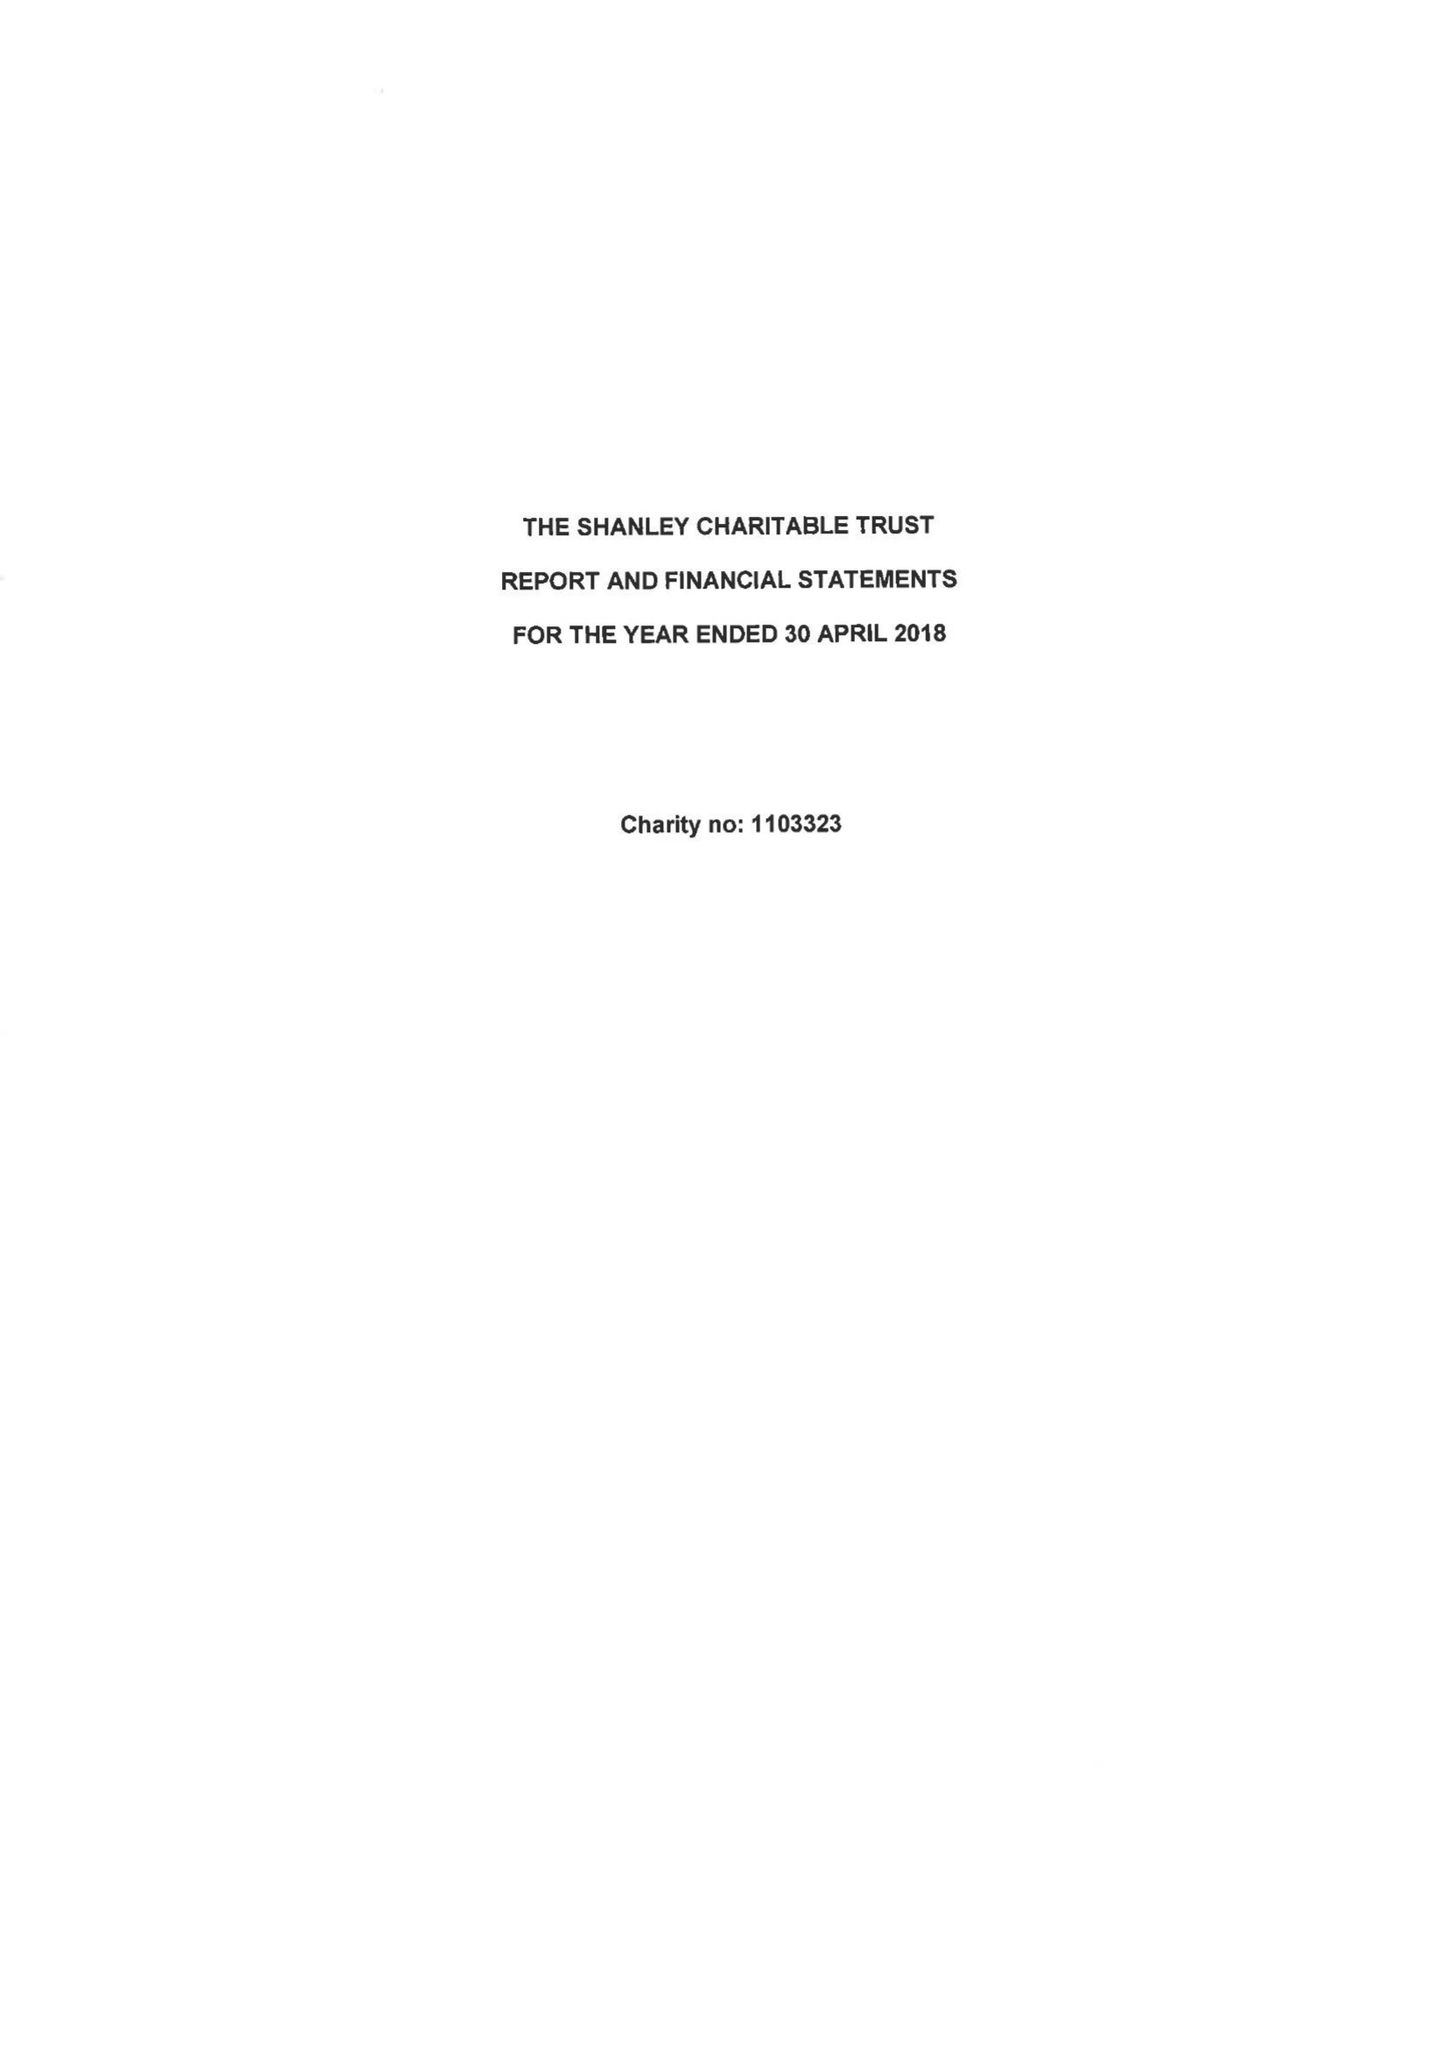What is the value for the address__post_town?
Answer the question using a single word or phrase. LONDON 